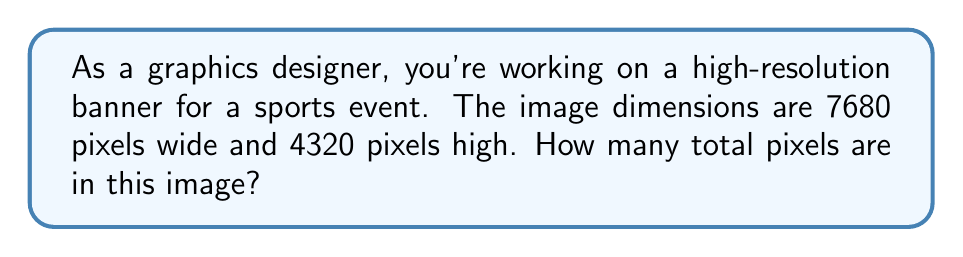Could you help me with this problem? To determine the total number of pixels in a high-resolution image, we need to multiply the width by the height. Let's break it down step-by-step:

1. Image width: 7680 pixels
2. Image height: 4320 pixels

The formula for calculating the total number of pixels is:

$$ \text{Total Pixels} = \text{Width} \times \text{Height} $$

Plugging in our values:

$$ \text{Total Pixels} = 7680 \times 4320 $$

Now, let's perform the multiplication:

$$ \text{Total Pixels} = 33,177,600 $$

Therefore, the total number of pixels in this high-resolution image is 33,177,600.
Answer: 33,177,600 pixels 